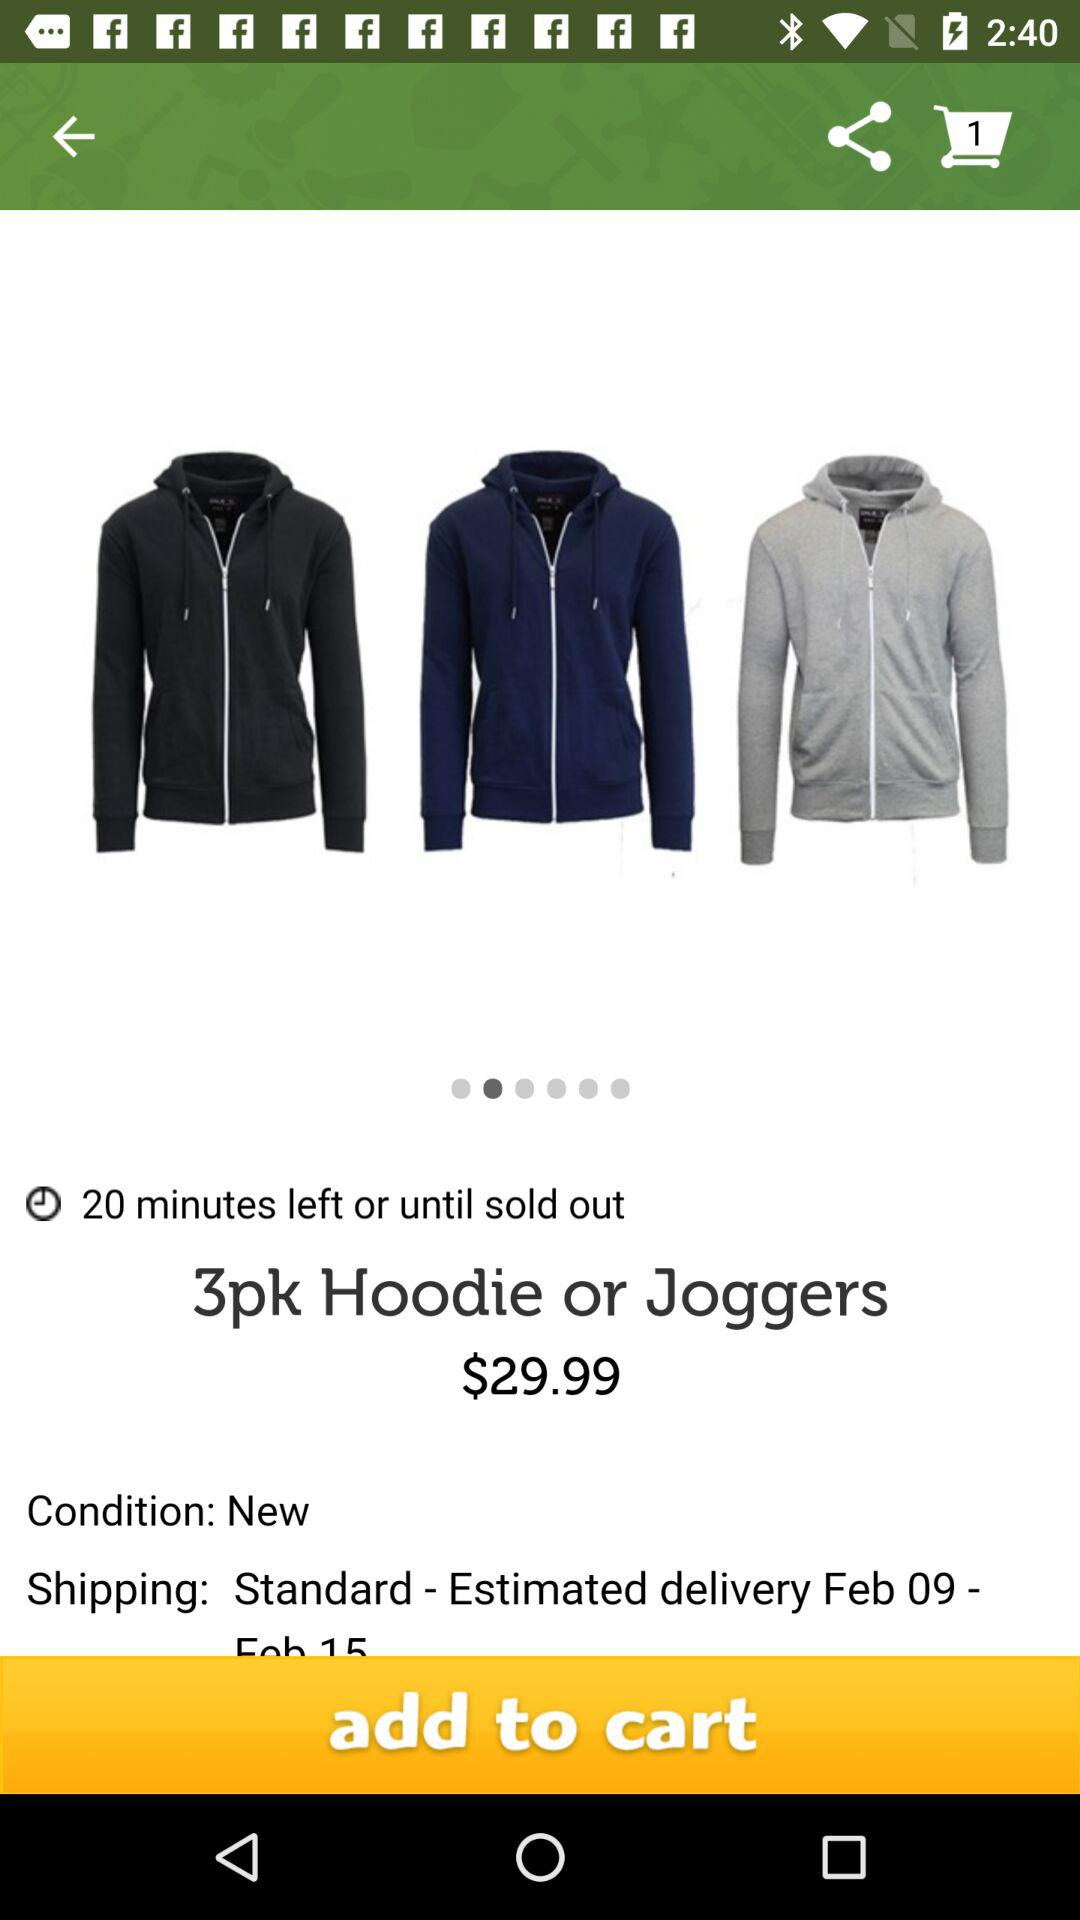What is the condition of the product? The condition of the product is new. 